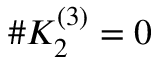<formula> <loc_0><loc_0><loc_500><loc_500>\# K _ { 2 } ^ { ( 3 ) } = 0</formula> 